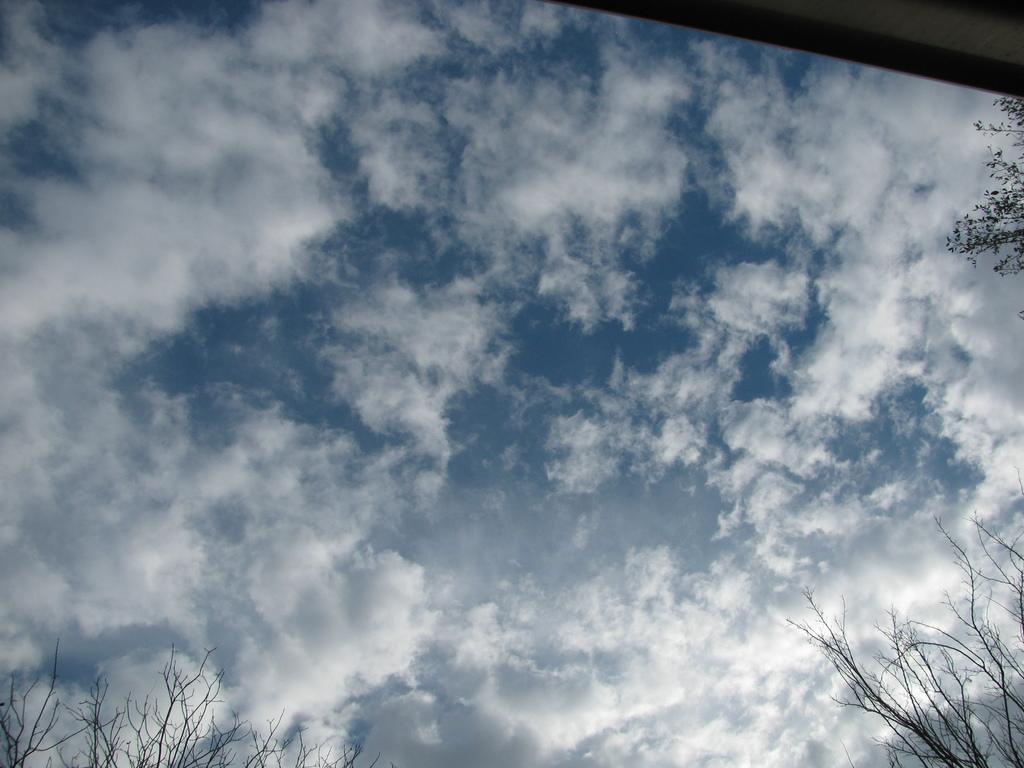Describe this image in one or two sentences. These are the clouds in the sky. I can see the trees. At the top of the image, that looks like a wall. 